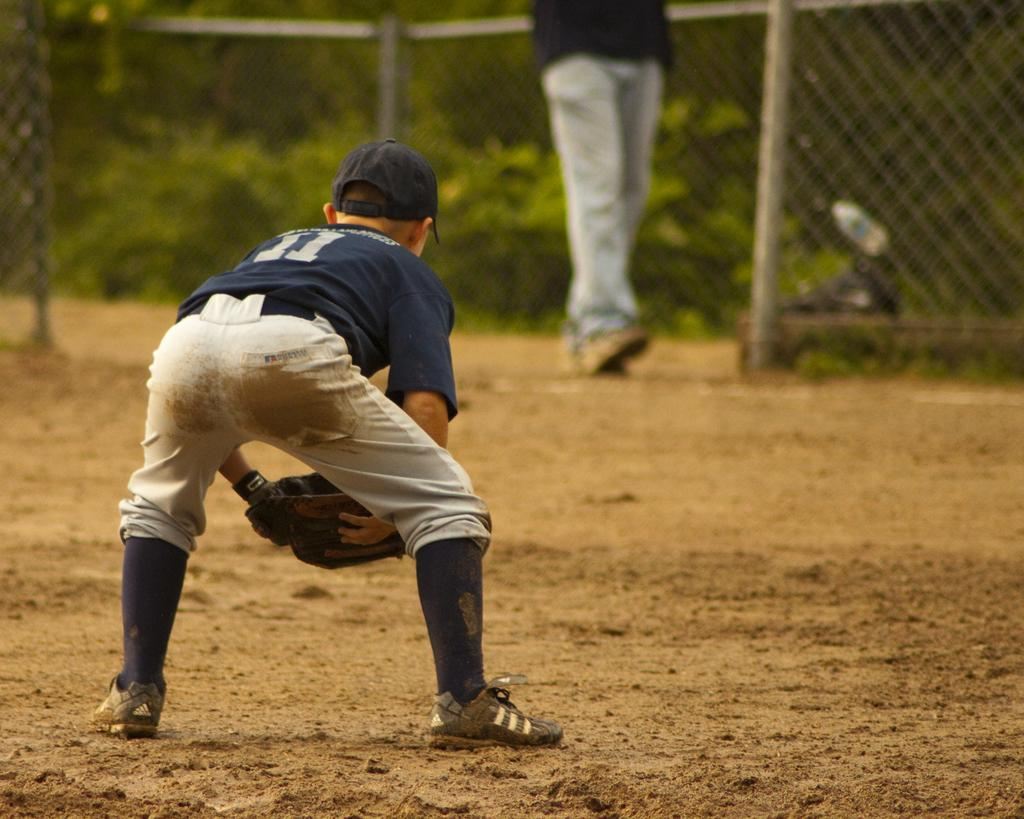Who is the main subject in the image? There is a boy in the image. What is the boy wearing on his head? The boy is wearing a cap. What is the boy wearing on his hands? The boy is wearing gloves. Can you describe the background of the image? There is a person, mesh fencing, and trees in the background of the image. What type of hose is being used by the boy in the image? There is no hose present in the image. Can you tell me what kind of car is parked near the boy in the image? There is no car present in the image. 